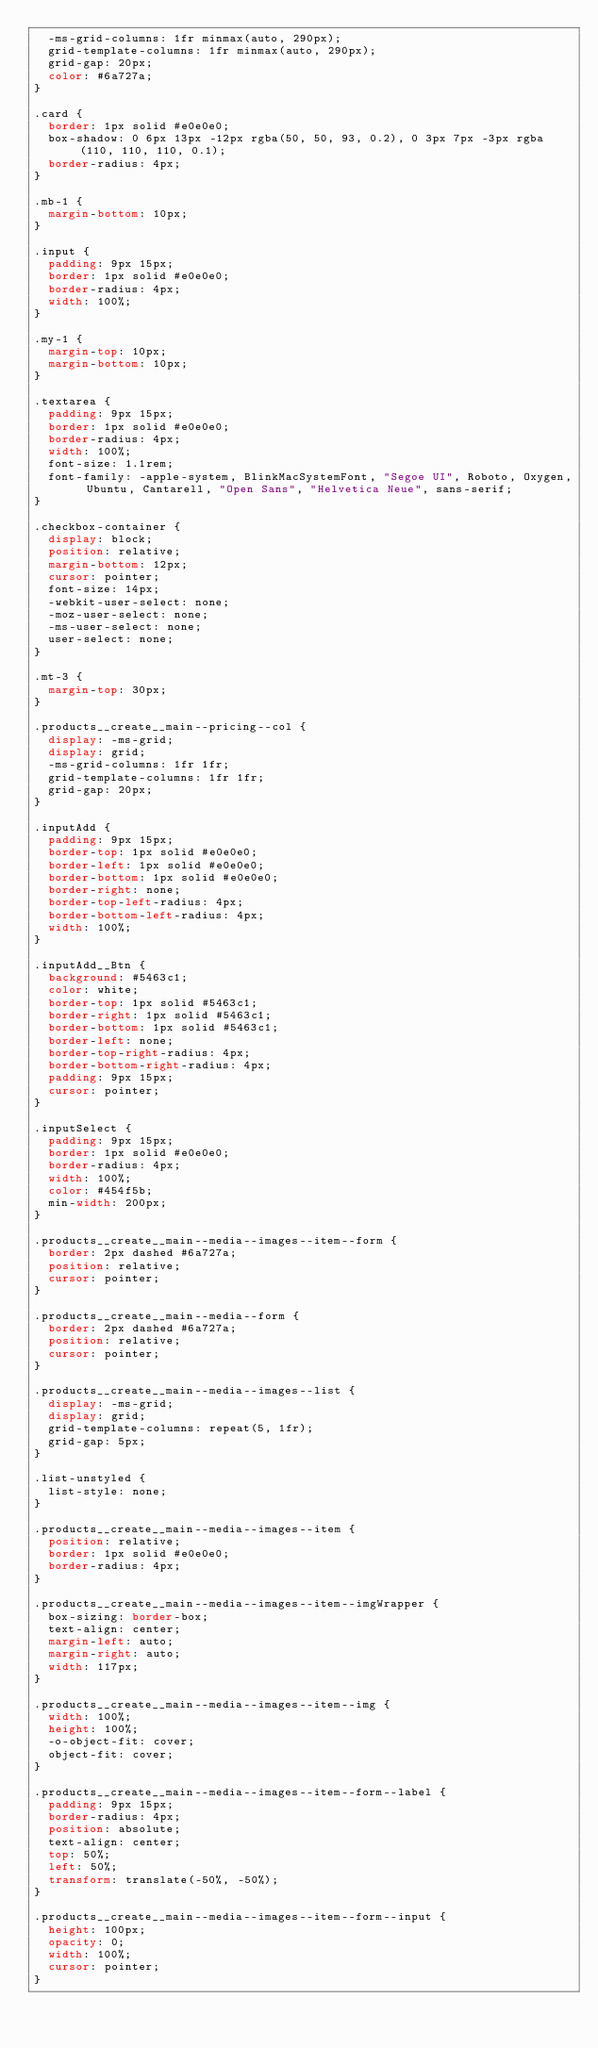Convert code to text. <code><loc_0><loc_0><loc_500><loc_500><_CSS_>  -ms-grid-columns: 1fr minmax(auto, 290px);
  grid-template-columns: 1fr minmax(auto, 290px);
  grid-gap: 20px;
  color: #6a727a;
}

.card {
  border: 1px solid #e0e0e0;
  box-shadow: 0 6px 13px -12px rgba(50, 50, 93, 0.2), 0 3px 7px -3px rgba(110, 110, 110, 0.1);
  border-radius: 4px;
}

.mb-1 {
  margin-bottom: 10px;
}

.input {
  padding: 9px 15px;
  border: 1px solid #e0e0e0;
  border-radius: 4px;
  width: 100%;
}

.my-1 {
  margin-top: 10px;
  margin-bottom: 10px;
}

.textarea {
  padding: 9px 15px;
  border: 1px solid #e0e0e0;
  border-radius: 4px;
  width: 100%;
  font-size: 1.1rem;
  font-family: -apple-system, BlinkMacSystemFont, "Segoe UI", Roboto, Oxygen, Ubuntu, Cantarell, "Open Sans", "Helvetica Neue", sans-serif;
}

.checkbox-container {
  display: block;
  position: relative;
  margin-bottom: 12px;
  cursor: pointer;
  font-size: 14px;
  -webkit-user-select: none;
  -moz-user-select: none;
  -ms-user-select: none;
  user-select: none;
}

.mt-3 {
  margin-top: 30px;
}

.products__create__main--pricing--col {
  display: -ms-grid;
  display: grid;
  -ms-grid-columns: 1fr 1fr;
  grid-template-columns: 1fr 1fr;
  grid-gap: 20px;
}

.inputAdd {
  padding: 9px 15px;
  border-top: 1px solid #e0e0e0;
  border-left: 1px solid #e0e0e0;
  border-bottom: 1px solid #e0e0e0;
  border-right: none;
  border-top-left-radius: 4px;
  border-bottom-left-radius: 4px;
  width: 100%;
}

.inputAdd__Btn {
  background: #5463c1;
  color: white;
  border-top: 1px solid #5463c1;
  border-right: 1px solid #5463c1;
  border-bottom: 1px solid #5463c1;
  border-left: none;
  border-top-right-radius: 4px;
  border-bottom-right-radius: 4px;
  padding: 9px 15px;
  cursor: pointer;
}

.inputSelect {
  padding: 9px 15px;
  border: 1px solid #e0e0e0;
  border-radius: 4px;
  width: 100%;
  color: #454f5b;
  min-width: 200px;
}

.products__create__main--media--images--item--form {
  border: 2px dashed #6a727a;
  position: relative;
  cursor: pointer;
}

.products__create__main--media--form {
  border: 2px dashed #6a727a;
  position: relative;
  cursor: pointer;
}

.products__create__main--media--images--list {
  display: -ms-grid;
  display: grid;
  grid-template-columns: repeat(5, 1fr);
  grid-gap: 5px;
}

.list-unstyled {
  list-style: none;
}

.products__create__main--media--images--item {
  position: relative;
  border: 1px solid #e0e0e0;
  border-radius: 4px;
}

.products__create__main--media--images--item--imgWrapper {
  box-sizing: border-box;
  text-align: center;
  margin-left: auto;
  margin-right: auto;
  width: 117px;
}

.products__create__main--media--images--item--img {
  width: 100%;
  height: 100%;
  -o-object-fit: cover;
  object-fit: cover;
}

.products__create__main--media--images--item--form--label {
  padding: 9px 15px;
  border-radius: 4px;
  position: absolute;
  text-align: center;
  top: 50%;
  left: 50%;
  transform: translate(-50%, -50%);
}

.products__create__main--media--images--item--form--input {
  height: 100px;
  opacity: 0;
  width: 100%;
  cursor: pointer;
}
</code> 